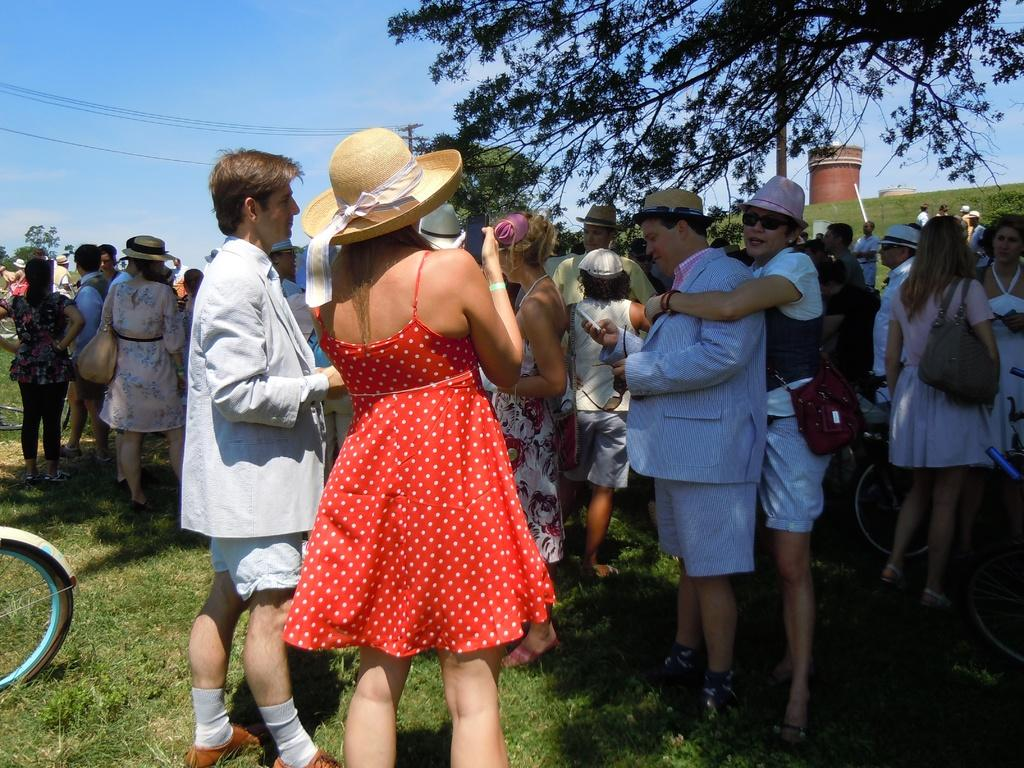How many people are present in the image? There are many people in the image. Can you describe any accessories worn by the people? Some people are wearing hats. What type of natural elements can be seen in the image? There are trees in the image. What structure is visible in the image? There appears to be a tower in the image. What type of sand can be seen covering the tower in the image? There is no sand present in the image, and the tower is not covered in any sand. 